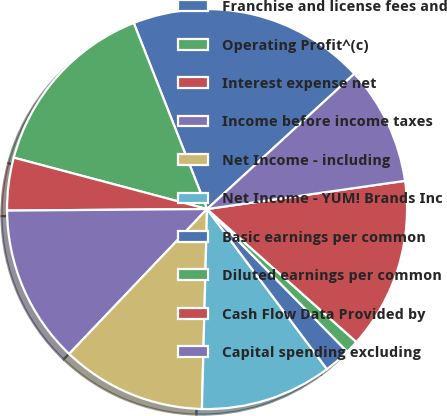Convert chart. <chart><loc_0><loc_0><loc_500><loc_500><pie_chart><fcel>Franchise and license fees and<fcel>Operating Profit^(c)<fcel>Interest expense net<fcel>Income before income taxes<fcel>Net Income - including<fcel>Net Income - YUM! Brands Inc<fcel>Basic earnings per common<fcel>Diluted earnings per common<fcel>Cash Flow Data Provided by<fcel>Capital spending excluding<nl><fcel>19.15%<fcel>14.89%<fcel>4.26%<fcel>12.77%<fcel>11.7%<fcel>10.64%<fcel>2.13%<fcel>1.06%<fcel>13.83%<fcel>9.57%<nl></chart> 